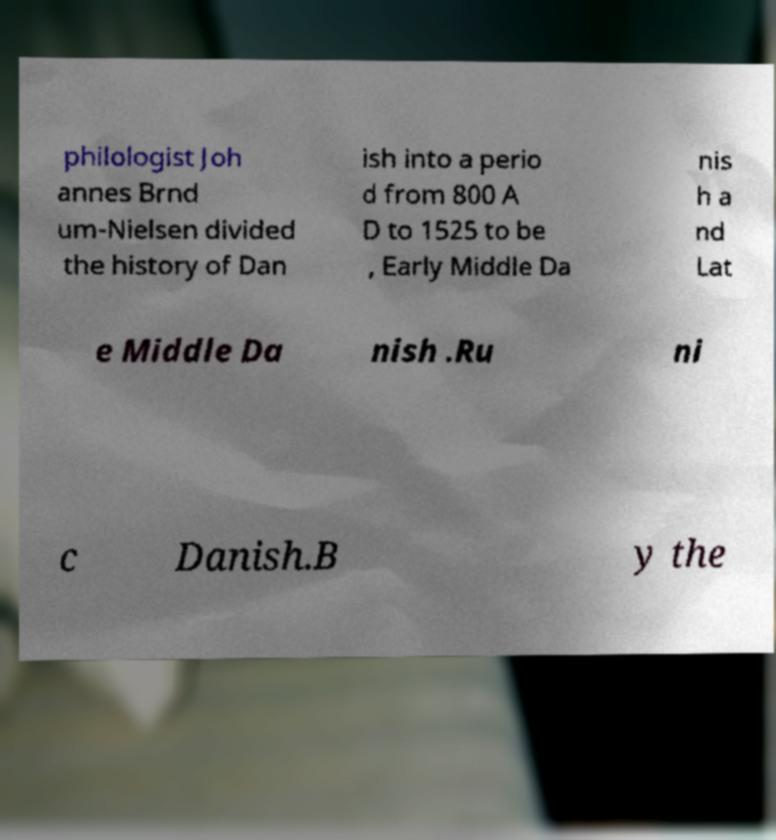For documentation purposes, I need the text within this image transcribed. Could you provide that? philologist Joh annes Brnd um-Nielsen divided the history of Dan ish into a perio d from 800 A D to 1525 to be , Early Middle Da nis h a nd Lat e Middle Da nish .Ru ni c Danish.B y the 